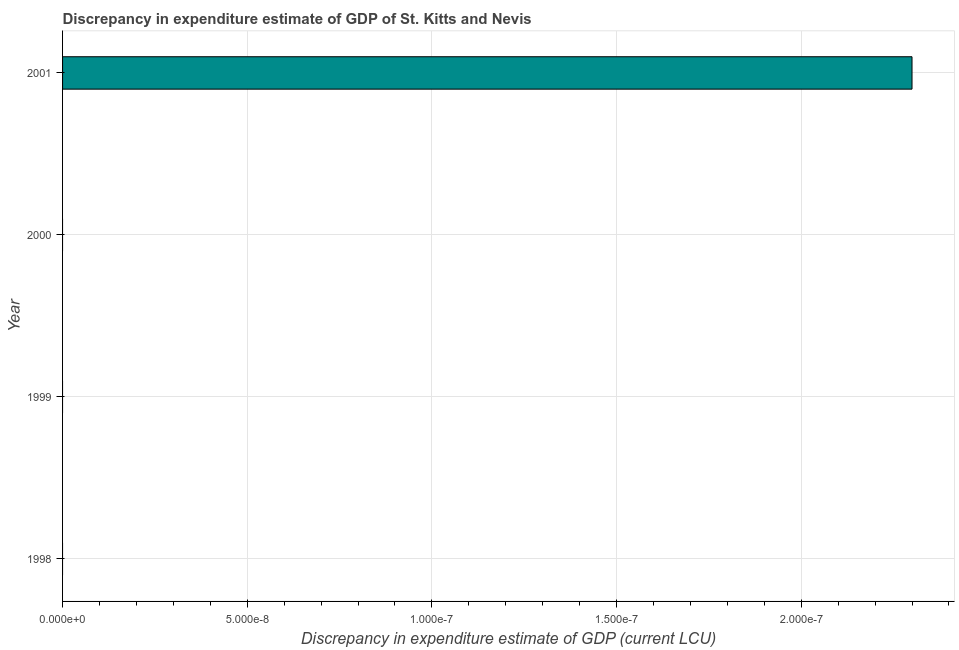Does the graph contain any zero values?
Offer a very short reply. Yes. What is the title of the graph?
Give a very brief answer. Discrepancy in expenditure estimate of GDP of St. Kitts and Nevis. What is the label or title of the X-axis?
Offer a terse response. Discrepancy in expenditure estimate of GDP (current LCU). What is the label or title of the Y-axis?
Your response must be concise. Year. Across all years, what is the maximum discrepancy in expenditure estimate of gdp?
Provide a short and direct response. 2.3e-7. Across all years, what is the minimum discrepancy in expenditure estimate of gdp?
Provide a succinct answer. 0. In which year was the discrepancy in expenditure estimate of gdp maximum?
Your answer should be very brief. 2001. What is the sum of the discrepancy in expenditure estimate of gdp?
Your answer should be very brief. 2.3e-7. What is the median discrepancy in expenditure estimate of gdp?
Provide a succinct answer. 0. In how many years, is the discrepancy in expenditure estimate of gdp greater than the average discrepancy in expenditure estimate of gdp taken over all years?
Make the answer very short. 1. How many bars are there?
Keep it short and to the point. 1. Are all the bars in the graph horizontal?
Keep it short and to the point. Yes. How many years are there in the graph?
Provide a succinct answer. 4. What is the difference between two consecutive major ticks on the X-axis?
Make the answer very short. 5e-8. Are the values on the major ticks of X-axis written in scientific E-notation?
Offer a very short reply. Yes. What is the Discrepancy in expenditure estimate of GDP (current LCU) in 1999?
Give a very brief answer. 0. What is the Discrepancy in expenditure estimate of GDP (current LCU) of 2001?
Ensure brevity in your answer.  2.3e-7. 